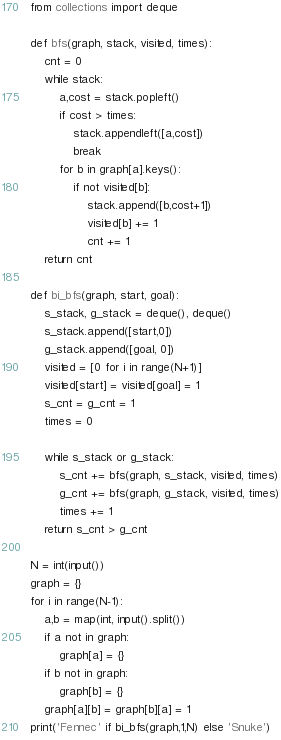<code> <loc_0><loc_0><loc_500><loc_500><_Python_>from collections import deque

def bfs(graph, stack, visited, times):
    cnt = 0
    while stack:
        a,cost = stack.popleft()
        if cost > times:
            stack.appendleft([a,cost])
            break
        for b in graph[a].keys():
            if not visited[b]:
                stack.append([b,cost+1])
                visited[b] += 1 
                cnt += 1
    return cnt

def bi_bfs(graph, start, goal):
    s_stack, g_stack = deque(), deque()
    s_stack.append([start,0])
    g_stack.append([goal, 0])
    visited = [0 for i in range(N+1)]
    visited[start] = visited[goal] = 1 
    s_cnt = g_cnt = 1
    times = 0

    while s_stack or g_stack:
        s_cnt += bfs(graph, s_stack, visited, times)
        g_cnt += bfs(graph, g_stack, visited, times)
        times += 1
    return s_cnt > g_cnt

N = int(input())
graph = {}
for i in range(N-1):
    a,b = map(int, input().split())
    if a not in graph:
        graph[a] = {}
    if b not in graph:
        graph[b] = {}
    graph[a][b] = graph[b][a] = 1
print('Fennec' if bi_bfs(graph,1,N) else 'Snuke')
</code> 